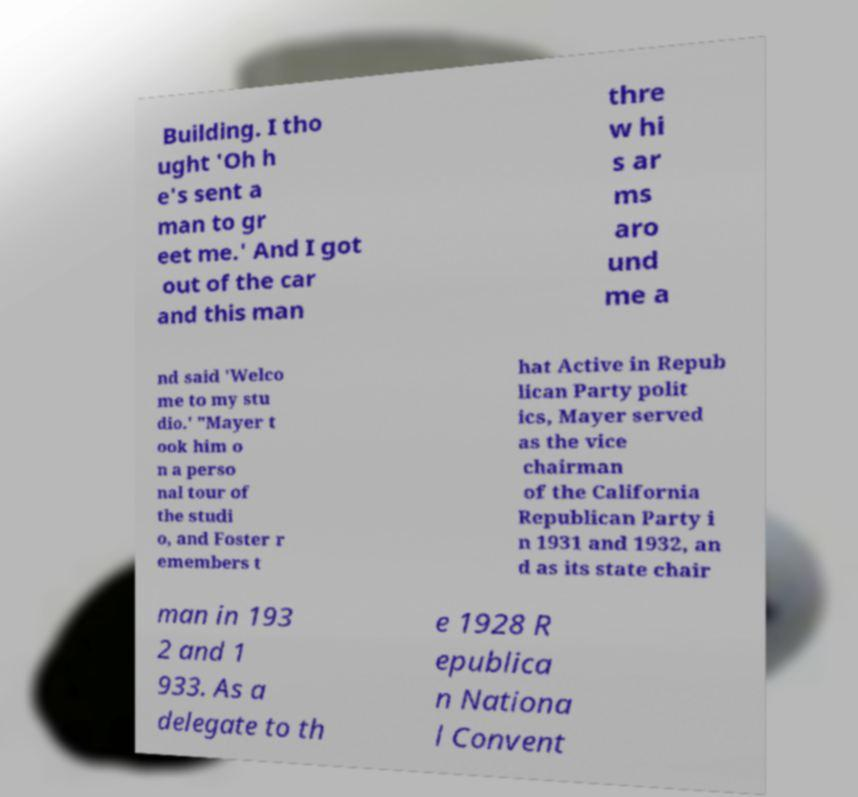Can you accurately transcribe the text from the provided image for me? Building. I tho ught 'Oh h e's sent a man to gr eet me.' And I got out of the car and this man thre w hi s ar ms aro und me a nd said 'Welco me to my stu dio.' "Mayer t ook him o n a perso nal tour of the studi o, and Foster r emembers t hat Active in Repub lican Party polit ics, Mayer served as the vice chairman of the California Republican Party i n 1931 and 1932, an d as its state chair man in 193 2 and 1 933. As a delegate to th e 1928 R epublica n Nationa l Convent 